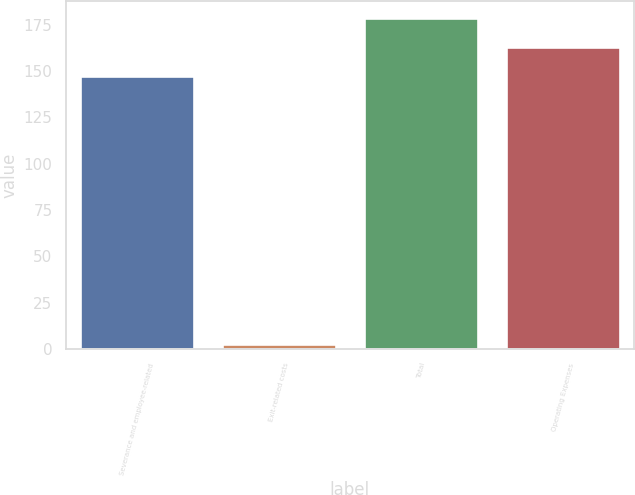Convert chart. <chart><loc_0><loc_0><loc_500><loc_500><bar_chart><fcel>Severance and employee-related<fcel>Exit-related costs<fcel>Total<fcel>Operating Expenses<nl><fcel>147<fcel>3<fcel>178.6<fcel>162.8<nl></chart> 